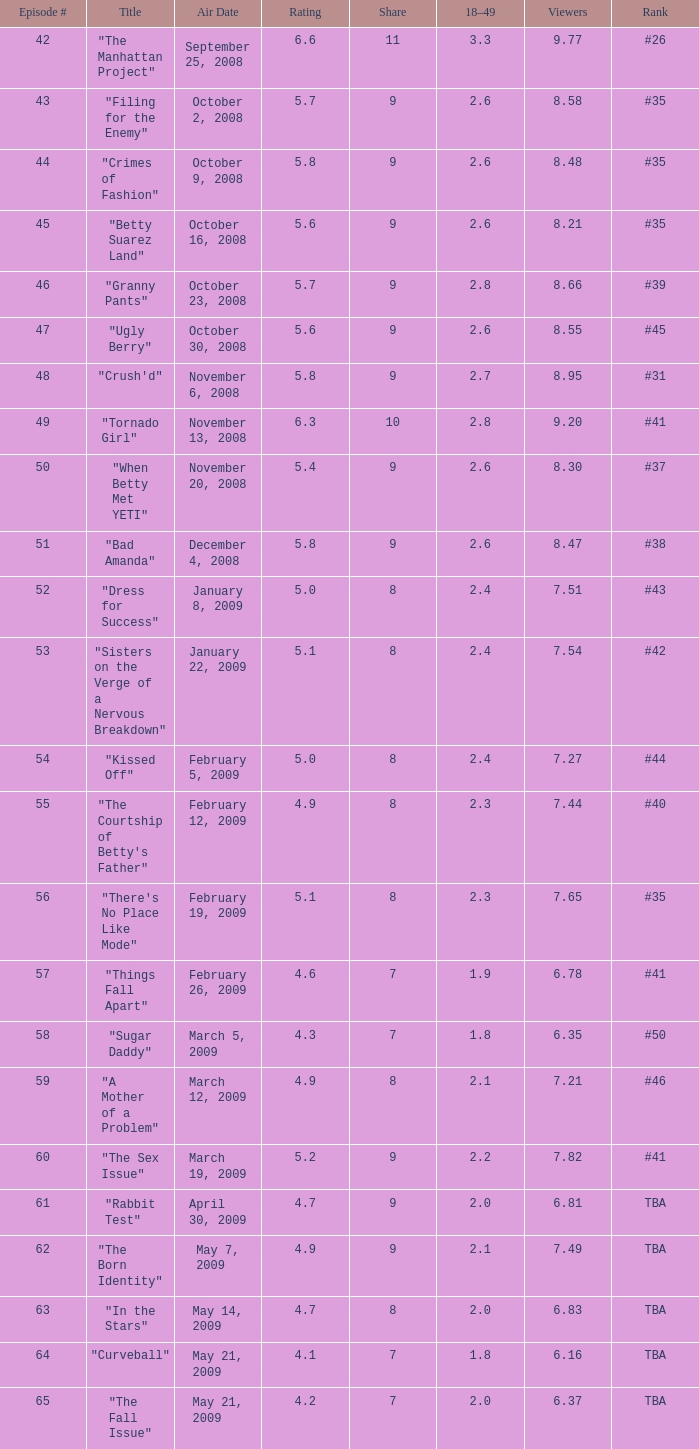9? April 30, 2009, May 14, 2009, May 21, 2009. 